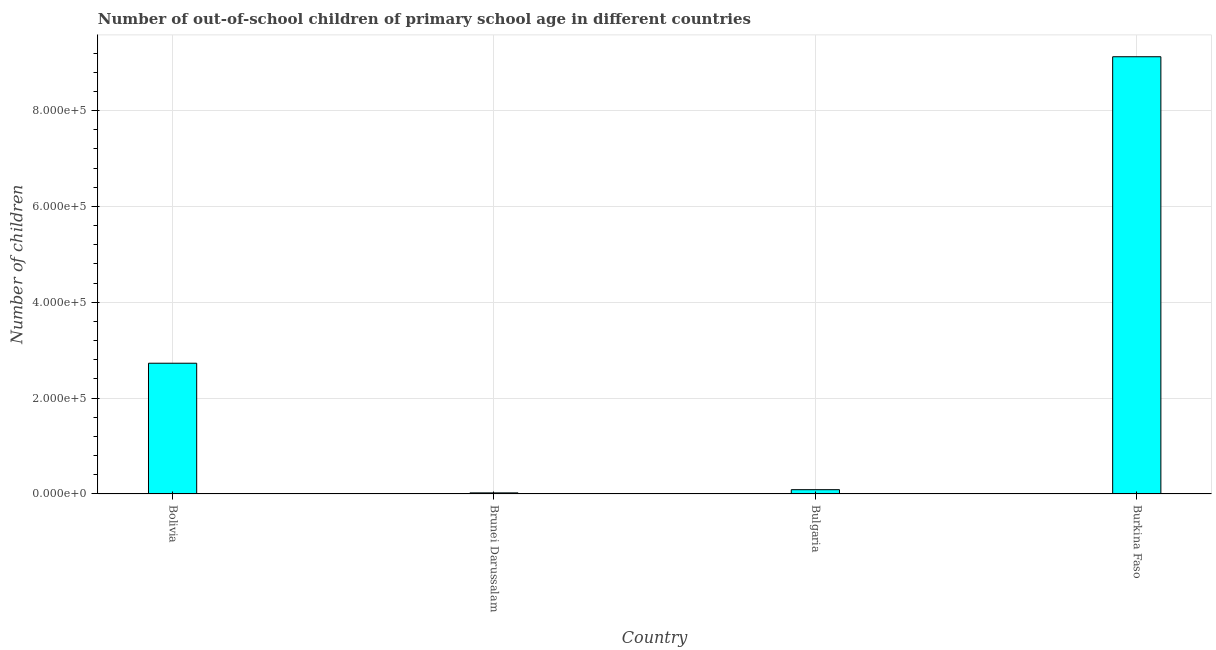Does the graph contain any zero values?
Your response must be concise. No. What is the title of the graph?
Your answer should be compact. Number of out-of-school children of primary school age in different countries. What is the label or title of the Y-axis?
Provide a short and direct response. Number of children. What is the number of out-of-school children in Bulgaria?
Provide a short and direct response. 8960. Across all countries, what is the maximum number of out-of-school children?
Keep it short and to the point. 9.12e+05. Across all countries, what is the minimum number of out-of-school children?
Your answer should be compact. 2275. In which country was the number of out-of-school children maximum?
Your response must be concise. Burkina Faso. In which country was the number of out-of-school children minimum?
Your response must be concise. Brunei Darussalam. What is the sum of the number of out-of-school children?
Keep it short and to the point. 1.20e+06. What is the difference between the number of out-of-school children in Bolivia and Brunei Darussalam?
Provide a short and direct response. 2.71e+05. What is the average number of out-of-school children per country?
Make the answer very short. 2.99e+05. What is the median number of out-of-school children?
Ensure brevity in your answer.  1.41e+05. In how many countries, is the number of out-of-school children greater than 720000 ?
Provide a succinct answer. 1. What is the ratio of the number of out-of-school children in Brunei Darussalam to that in Bulgaria?
Make the answer very short. 0.25. Is the difference between the number of out-of-school children in Bolivia and Bulgaria greater than the difference between any two countries?
Offer a very short reply. No. What is the difference between the highest and the second highest number of out-of-school children?
Provide a succinct answer. 6.40e+05. What is the difference between the highest and the lowest number of out-of-school children?
Your answer should be very brief. 9.10e+05. How many bars are there?
Offer a very short reply. 4. Are all the bars in the graph horizontal?
Your response must be concise. No. What is the Number of children of Bolivia?
Provide a succinct answer. 2.73e+05. What is the Number of children in Brunei Darussalam?
Your answer should be compact. 2275. What is the Number of children of Bulgaria?
Keep it short and to the point. 8960. What is the Number of children in Burkina Faso?
Keep it short and to the point. 9.12e+05. What is the difference between the Number of children in Bolivia and Brunei Darussalam?
Your answer should be very brief. 2.71e+05. What is the difference between the Number of children in Bolivia and Bulgaria?
Your answer should be very brief. 2.64e+05. What is the difference between the Number of children in Bolivia and Burkina Faso?
Offer a very short reply. -6.40e+05. What is the difference between the Number of children in Brunei Darussalam and Bulgaria?
Provide a short and direct response. -6685. What is the difference between the Number of children in Brunei Darussalam and Burkina Faso?
Keep it short and to the point. -9.10e+05. What is the difference between the Number of children in Bulgaria and Burkina Faso?
Your response must be concise. -9.03e+05. What is the ratio of the Number of children in Bolivia to that in Brunei Darussalam?
Ensure brevity in your answer.  119.92. What is the ratio of the Number of children in Bolivia to that in Bulgaria?
Your response must be concise. 30.45. What is the ratio of the Number of children in Bolivia to that in Burkina Faso?
Your response must be concise. 0.3. What is the ratio of the Number of children in Brunei Darussalam to that in Bulgaria?
Your answer should be very brief. 0.25. What is the ratio of the Number of children in Brunei Darussalam to that in Burkina Faso?
Provide a succinct answer. 0. What is the ratio of the Number of children in Bulgaria to that in Burkina Faso?
Provide a succinct answer. 0.01. 